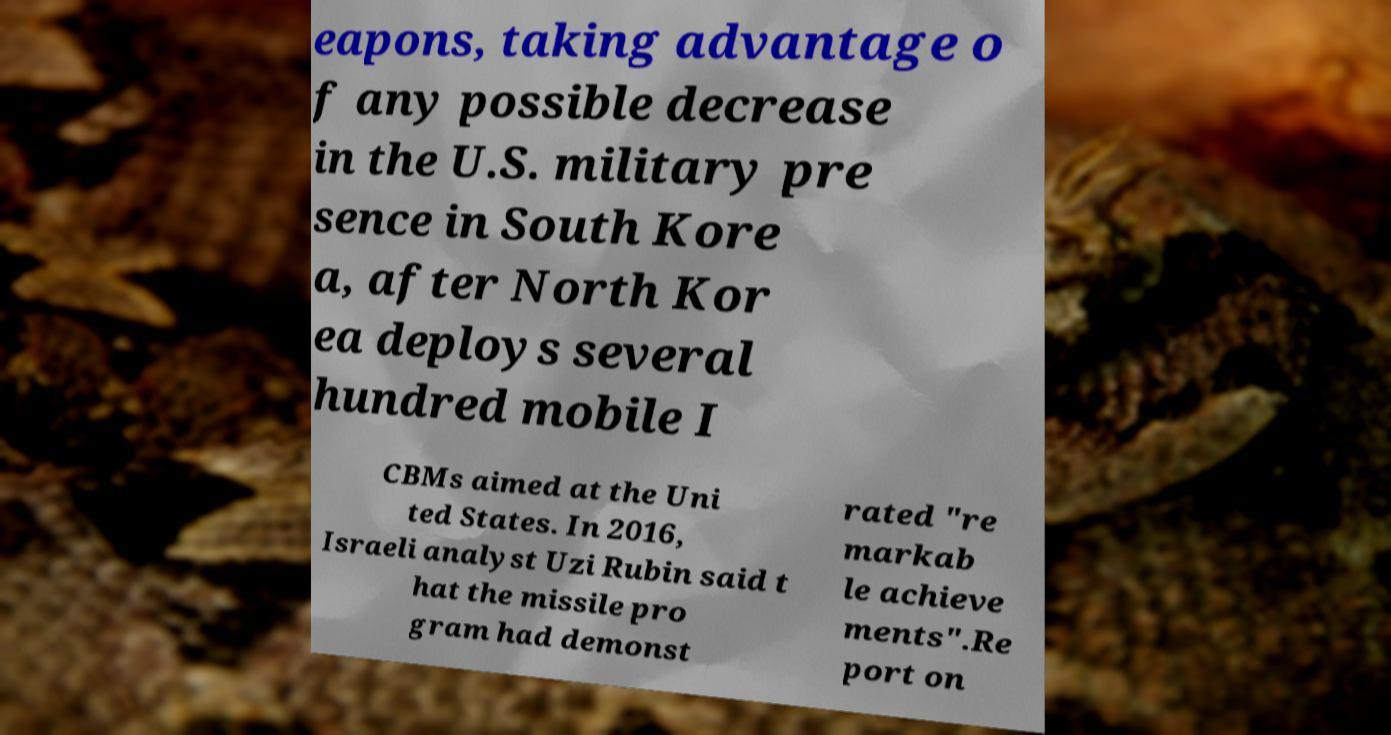Could you assist in decoding the text presented in this image and type it out clearly? eapons, taking advantage o f any possible decrease in the U.S. military pre sence in South Kore a, after North Kor ea deploys several hundred mobile I CBMs aimed at the Uni ted States. In 2016, Israeli analyst Uzi Rubin said t hat the missile pro gram had demonst rated "re markab le achieve ments".Re port on 